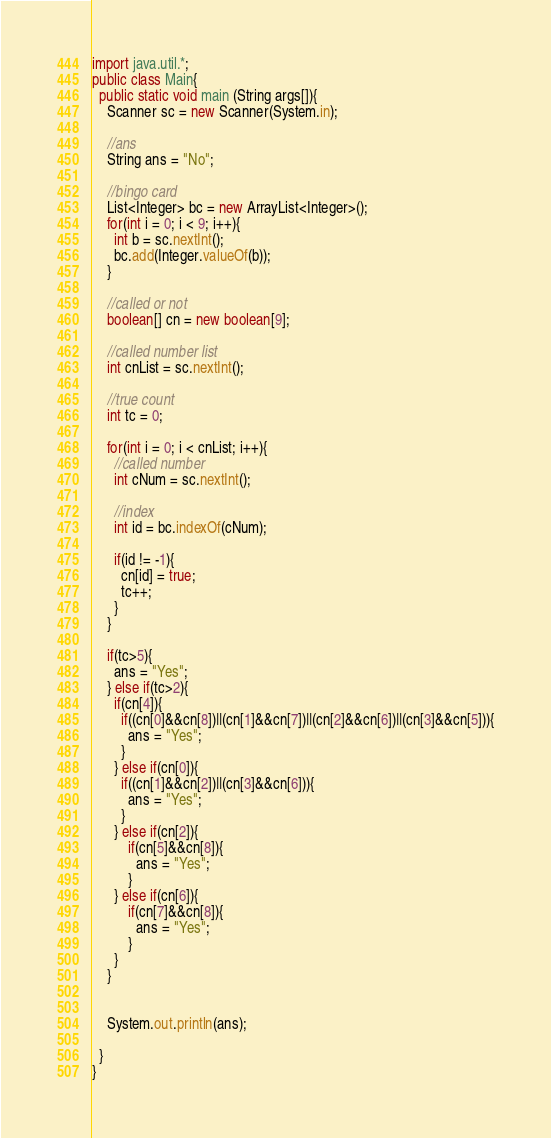<code> <loc_0><loc_0><loc_500><loc_500><_Java_>import java.util.*;
public class Main{
  public static void main (String args[]){
    Scanner sc = new Scanner(System.in);

    //ans
    String ans = "No";

    //bingo card
    List<Integer> bc = new ArrayList<Integer>();
    for(int i = 0; i < 9; i++){
      int b = sc.nextInt();
      bc.add(Integer.valueOf(b));      
    }
    
    //called or not
    boolean[] cn = new boolean[9];
    
    //called number list
    int cnList = sc.nextInt();
    
    //true count
    int tc = 0;
    
    for(int i = 0; i < cnList; i++){
      //called number
      int cNum = sc.nextInt();
      
      //index
      int id = bc.indexOf(cNum);

      if(id != -1){
        cn[id] = true;
        tc++;
      }
    }
    
    if(tc>5){
      ans = "Yes";
    } else if(tc>2){
      if(cn[4]){
        if((cn[0]&&cn[8])||(cn[1]&&cn[7])||(cn[2]&&cn[6])||(cn[3]&&cn[5])){
          ans = "Yes";
        }
      } else if(cn[0]){
        if((cn[1]&&cn[2])||(cn[3]&&cn[6])){
          ans = "Yes";
        }
      } else if(cn[2]){
          if(cn[5]&&cn[8]){
            ans = "Yes";
          }
      } else if(cn[6]){
          if(cn[7]&&cn[8]){
            ans = "Yes";
          }
      }
    }
    
    
    System.out.println(ans);
    
  }
}</code> 